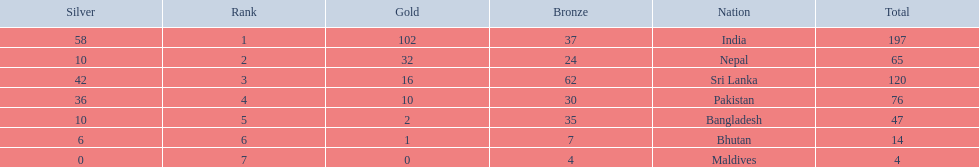What were the total amount won of medals by nations in the 1999 south asian games? 197, 65, 120, 76, 47, 14, 4. Which amount was the lowest? 4. I'm looking to parse the entire table for insights. Could you assist me with that? {'header': ['Silver', 'Rank', 'Gold', 'Bronze', 'Nation', 'Total'], 'rows': [['58', '1', '102', '37', 'India', '197'], ['10', '2', '32', '24', 'Nepal', '65'], ['42', '3', '16', '62', 'Sri Lanka', '120'], ['36', '4', '10', '30', 'Pakistan', '76'], ['10', '5', '2', '35', 'Bangladesh', '47'], ['6', '6', '1', '7', 'Bhutan', '14'], ['0', '7', '0', '4', 'Maldives', '4']]} Which nation had this amount? Maldives. 